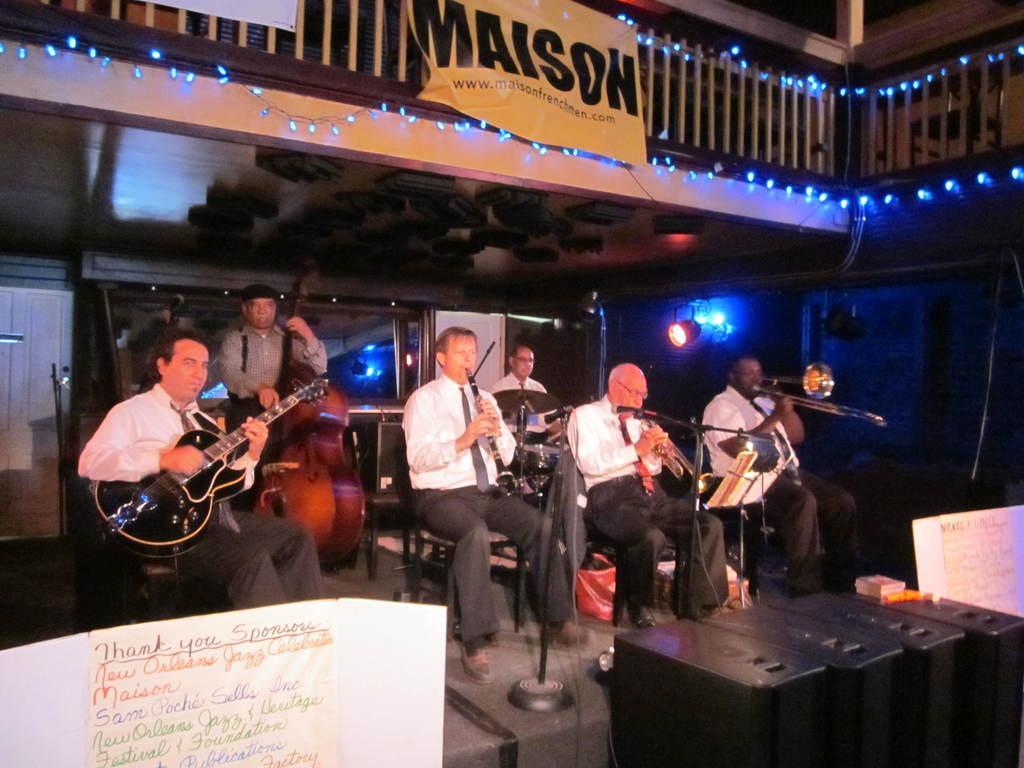Describe this image in one or two sentences. At the top we can see a balcony and there is a banner. We can see lights here. We can see all the men sitting on a chairs and playing musical instruments. These are mike's. This is a platform. Here we can see a chart paper. these are electronic devices. 